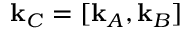<formula> <loc_0><loc_0><loc_500><loc_500>k _ { C } = [ k _ { A } , k _ { B } ]</formula> 